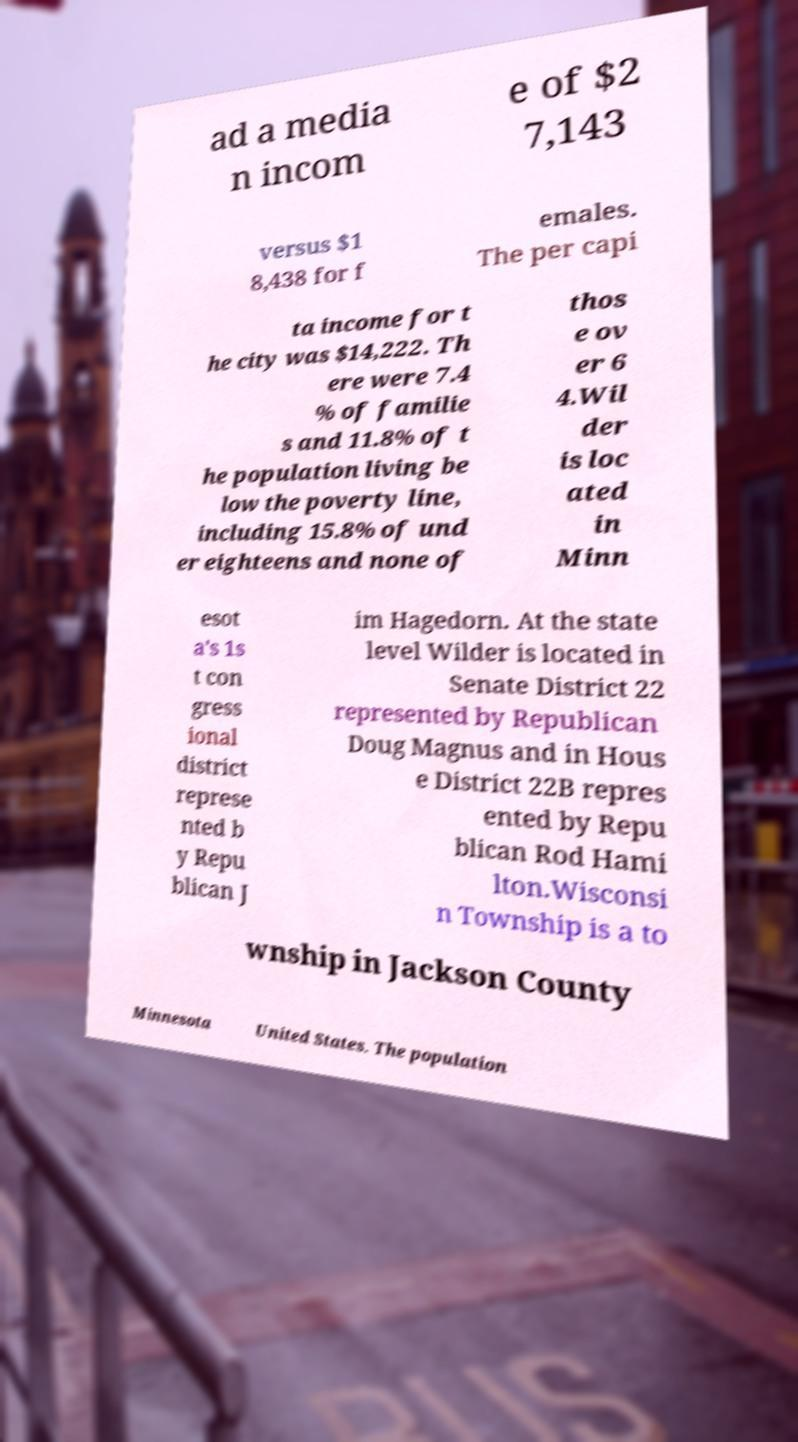What messages or text are displayed in this image? I need them in a readable, typed format. ad a media n incom e of $2 7,143 versus $1 8,438 for f emales. The per capi ta income for t he city was $14,222. Th ere were 7.4 % of familie s and 11.8% of t he population living be low the poverty line, including 15.8% of und er eighteens and none of thos e ov er 6 4.Wil der is loc ated in Minn esot a's 1s t con gress ional district represe nted b y Repu blican J im Hagedorn. At the state level Wilder is located in Senate District 22 represented by Republican Doug Magnus and in Hous e District 22B repres ented by Repu blican Rod Hami lton.Wisconsi n Township is a to wnship in Jackson County Minnesota United States. The population 